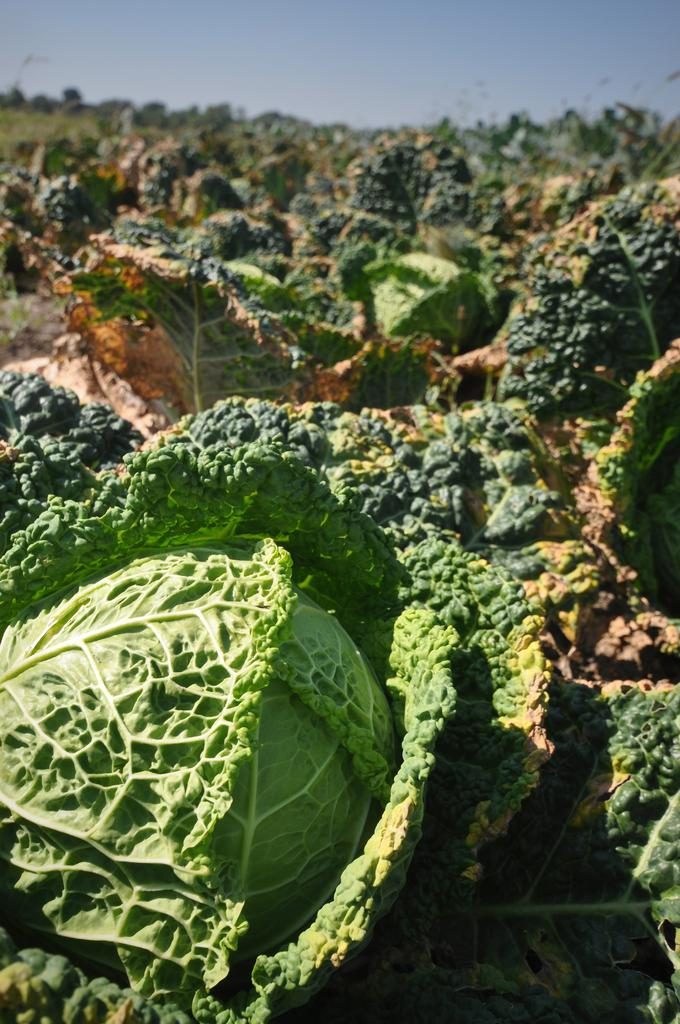What type of vegetable is present in the image? The image contains cabbages. What part of the cabbages is visible? The cabbages have leaves. What can be seen in the background of the image? There are trees visible in the image. How would you describe the weather based on the sky in the image? The sky is cloudy in the image. What type of harmony is being practiced by the religious group in the image? There is no religious group or any indication of harmony in the image; it features cabbages with leaves and trees in the background. What branch of the tree is depicted in the image? There is no specific branch of a tree depicted in the image; only trees in general are visible in the background. 